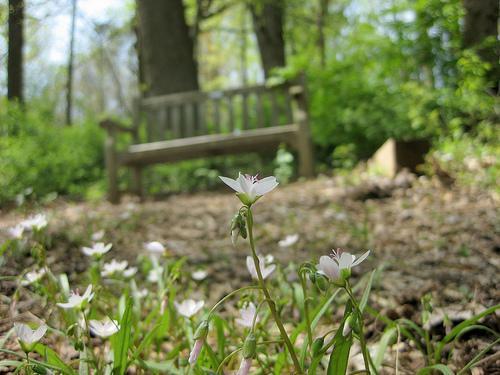How many benches are there?
Give a very brief answer. 1. 